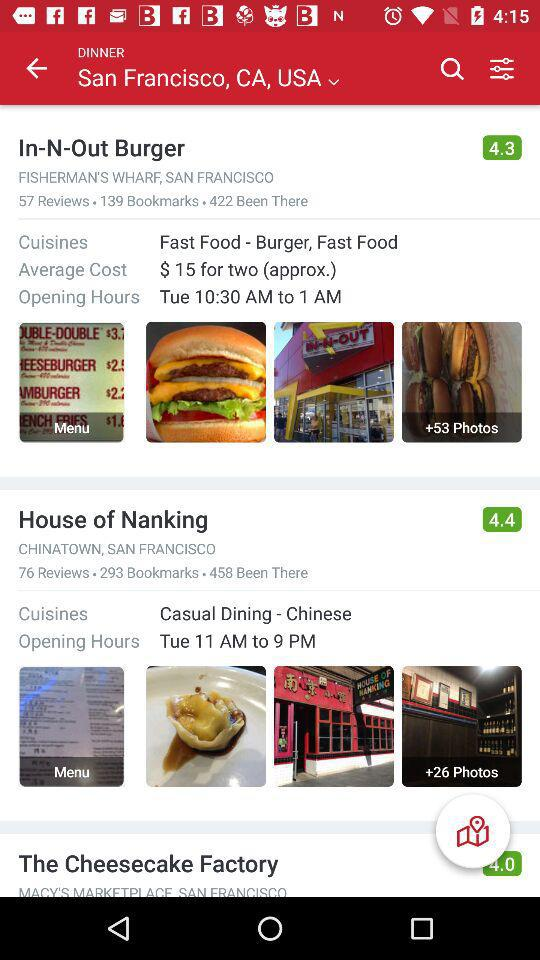How many bookmarks are there for "In-N-Out Burger"? There are 139 bookmarks for "In-N-Out Burger". 